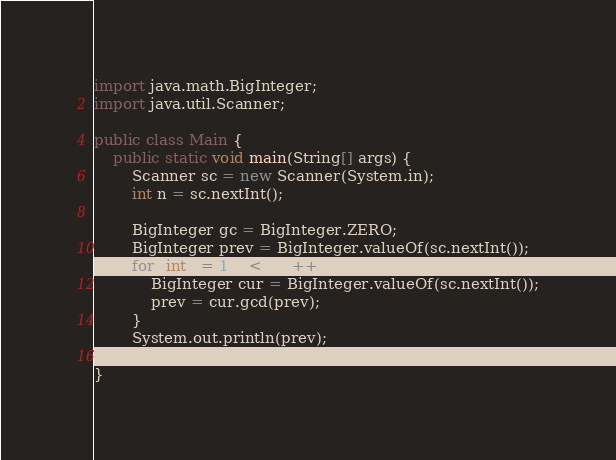<code> <loc_0><loc_0><loc_500><loc_500><_Java_>import java.math.BigInteger;
import java.util.Scanner;

public class Main {
    public static void main(String[] args) {
        Scanner sc = new Scanner(System.in);
        int n = sc.nextInt();

        BigInteger gc = BigInteger.ZERO;
        BigInteger prev = BigInteger.valueOf(sc.nextInt());
        for (int i = 1; i < n; i++) {
            BigInteger cur = BigInteger.valueOf(sc.nextInt());
            prev = cur.gcd(prev);
        }
        System.out.println(prev);
    }
}</code> 